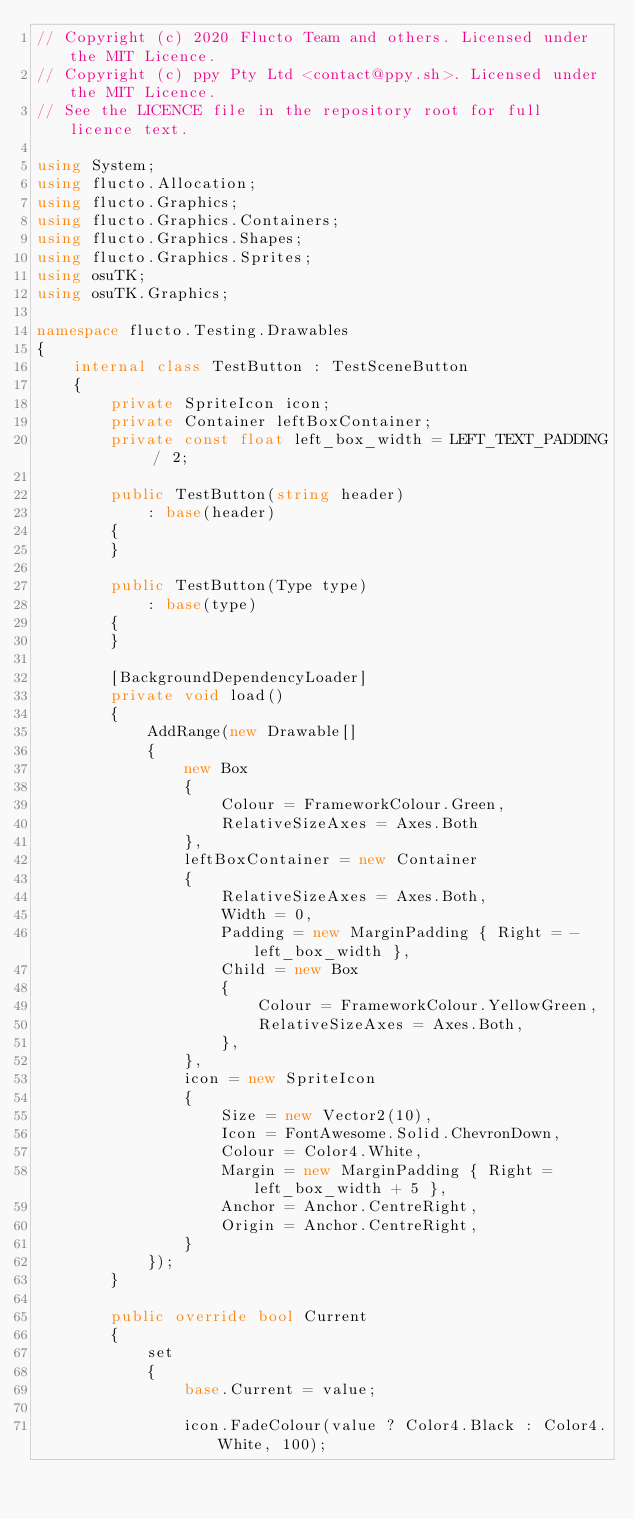<code> <loc_0><loc_0><loc_500><loc_500><_C#_>// Copyright (c) 2020 Flucto Team and others. Licensed under the MIT Licence.
// Copyright (c) ppy Pty Ltd <contact@ppy.sh>. Licensed under the MIT Licence.
// See the LICENCE file in the repository root for full licence text.

using System;
using flucto.Allocation;
using flucto.Graphics;
using flucto.Graphics.Containers;
using flucto.Graphics.Shapes;
using flucto.Graphics.Sprites;
using osuTK;
using osuTK.Graphics;

namespace flucto.Testing.Drawables
{
    internal class TestButton : TestSceneButton
    {
        private SpriteIcon icon;
        private Container leftBoxContainer;
        private const float left_box_width = LEFT_TEXT_PADDING / 2;

        public TestButton(string header)
            : base(header)
        {
        }

        public TestButton(Type type)
            : base(type)
        {
        }

        [BackgroundDependencyLoader]
        private void load()
        {
            AddRange(new Drawable[]
            {
                new Box
                {
                    Colour = FrameworkColour.Green,
                    RelativeSizeAxes = Axes.Both
                },
                leftBoxContainer = new Container
                {
                    RelativeSizeAxes = Axes.Both,
                    Width = 0,
                    Padding = new MarginPadding { Right = -left_box_width },
                    Child = new Box
                    {
                        Colour = FrameworkColour.YellowGreen,
                        RelativeSizeAxes = Axes.Both,
                    },
                },
                icon = new SpriteIcon
                {
                    Size = new Vector2(10),
                    Icon = FontAwesome.Solid.ChevronDown,
                    Colour = Color4.White,
                    Margin = new MarginPadding { Right = left_box_width + 5 },
                    Anchor = Anchor.CentreRight,
                    Origin = Anchor.CentreRight,
                }
            });
        }

        public override bool Current
        {
            set
            {
                base.Current = value;

                icon.FadeColour(value ? Color4.Black : Color4.White, 100);
</code> 